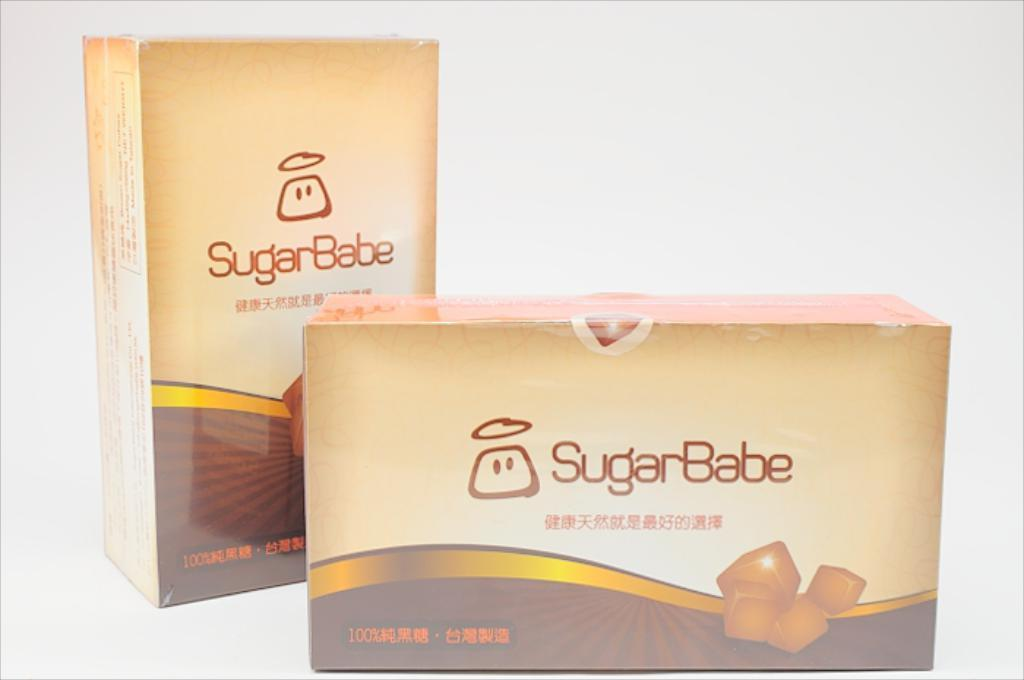<image>
Describe the image concisely. A brown box of Sugar Babe chocolates with some asian writing as well. 